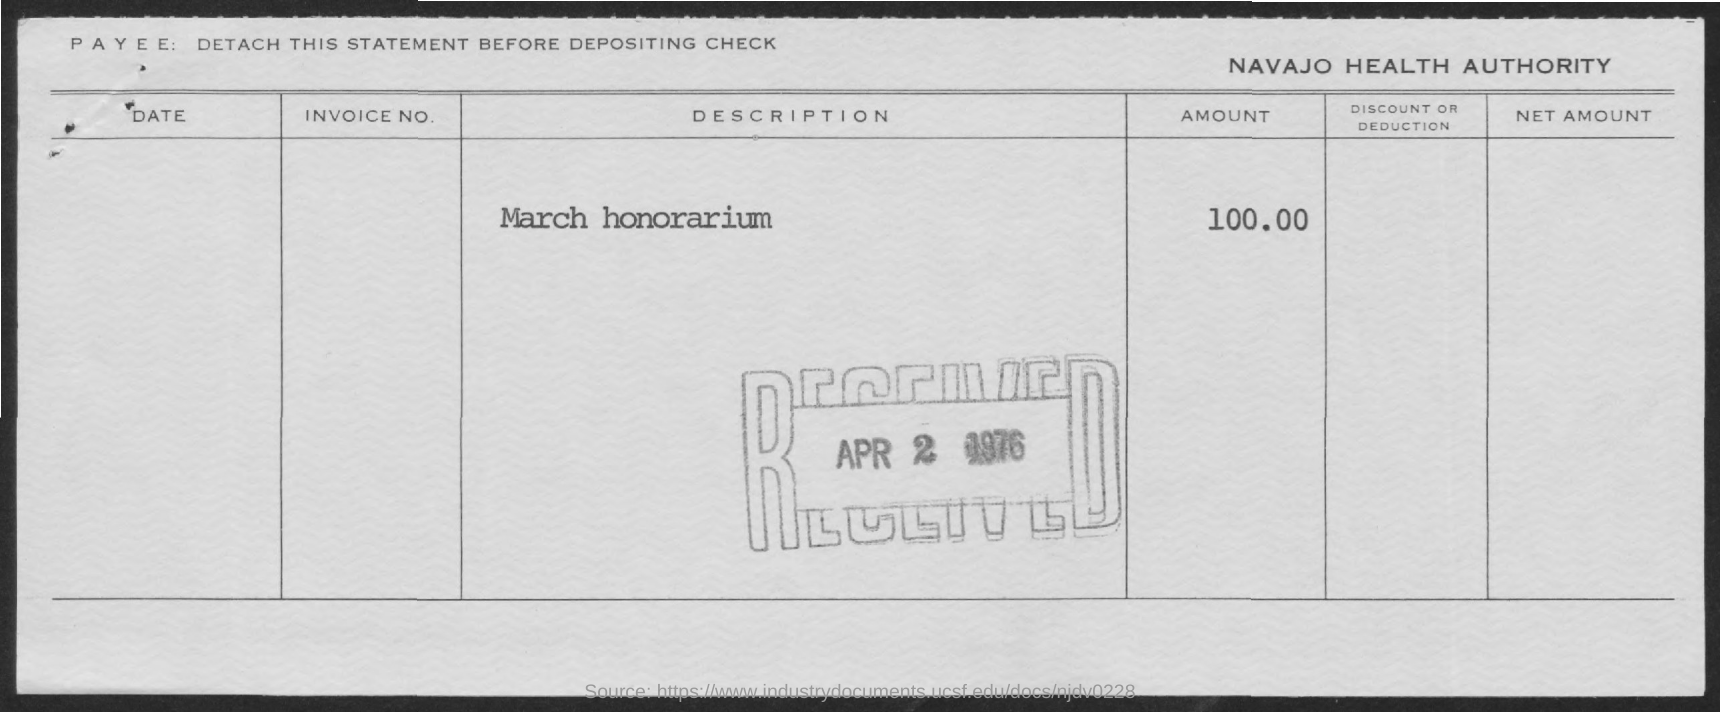What is the received date of this statement?
Your answer should be compact. Apr 2 1976. What is the amount given in the statement?
Offer a terse response. 100.00. 